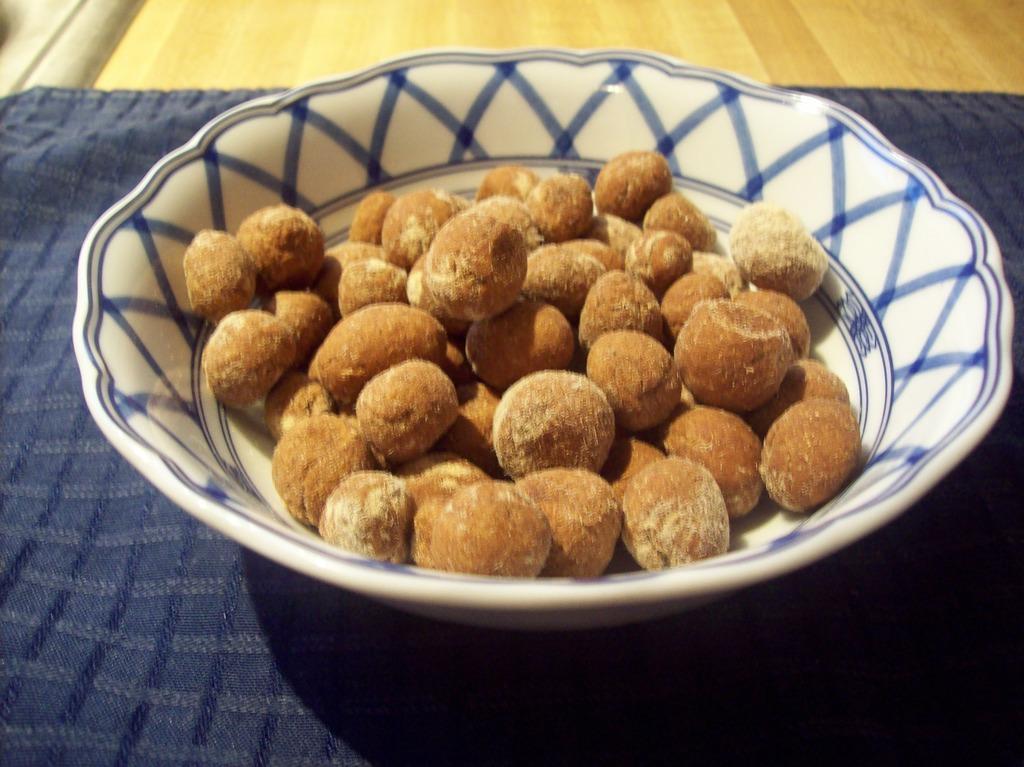Describe this image in one or two sentences. In this picture, it looks like a wooden table and on the table there is a cloth and a bowl. In the bowl there are some food items. 